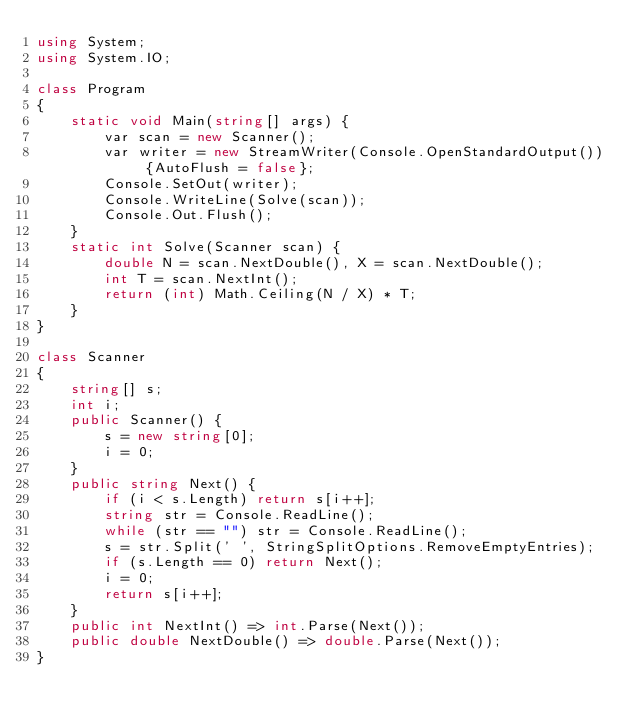Convert code to text. <code><loc_0><loc_0><loc_500><loc_500><_C#_>using System;
using System.IO;

class Program
{
    static void Main(string[] args) {
        var scan = new Scanner();
        var writer = new StreamWriter(Console.OpenStandardOutput()) {AutoFlush = false};
        Console.SetOut(writer);
        Console.WriteLine(Solve(scan));
        Console.Out.Flush();
    }
    static int Solve(Scanner scan) {
        double N = scan.NextDouble(), X = scan.NextDouble();
        int T = scan.NextInt();
        return (int) Math.Ceiling(N / X) * T;
    }
}

class Scanner
{
    string[] s;
    int i;
    public Scanner() {
        s = new string[0];
        i = 0;
    }
    public string Next() {
        if (i < s.Length) return s[i++];
        string str = Console.ReadLine();
        while (str == "") str = Console.ReadLine();
        s = str.Split(' ', StringSplitOptions.RemoveEmptyEntries);
        if (s.Length == 0) return Next();
        i = 0;
        return s[i++];
    }
    public int NextInt() => int.Parse(Next());
    public double NextDouble() => double.Parse(Next());
}</code> 